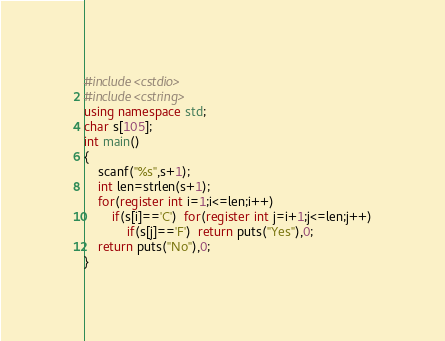<code> <loc_0><loc_0><loc_500><loc_500><_C++_>#include<cstdio>
#include<cstring>
using namespace std;
char s[105];
int main()
{
    scanf("%s",s+1);
    int len=strlen(s+1);
    for(register int i=1;i<=len;i++)
        if(s[i]=='C')  for(register int j=i+1;j<=len;j++)
            if(s[j]=='F')  return puts("Yes"),0;
    return puts("No"),0;
}</code> 